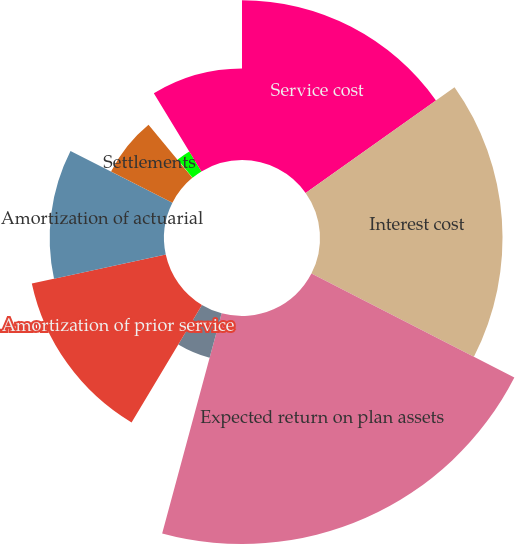Convert chart. <chart><loc_0><loc_0><loc_500><loc_500><pie_chart><fcel>Service cost<fcel>Interest cost<fcel>Expected return on plan assets<fcel>Amortization of transition<fcel>Amortization of prior service<fcel>Amortization of actuarial<fcel>Settlements<fcel>Curtailments<fcel>Special termination benefits<fcel>Net periodic (benefit) cost<nl><fcel>15.18%<fcel>17.34%<fcel>21.66%<fcel>4.38%<fcel>13.02%<fcel>10.86%<fcel>6.54%<fcel>0.06%<fcel>2.22%<fcel>8.7%<nl></chart> 